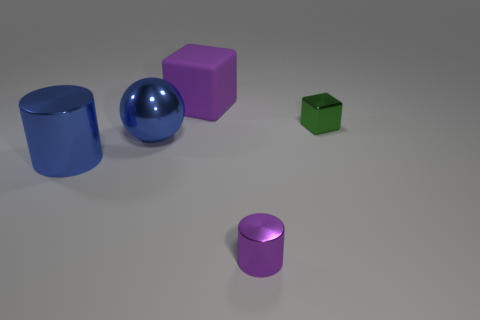What can you infer about the light source in this image? The shadows cast by the objects suggest that there is a single light source located off to the upper right of the image, not directly visible in the scene. The way the light reflects off the blue metallic objects also indicates the light source is fairly strong and possibly diffused slightly to reduce harshness. 